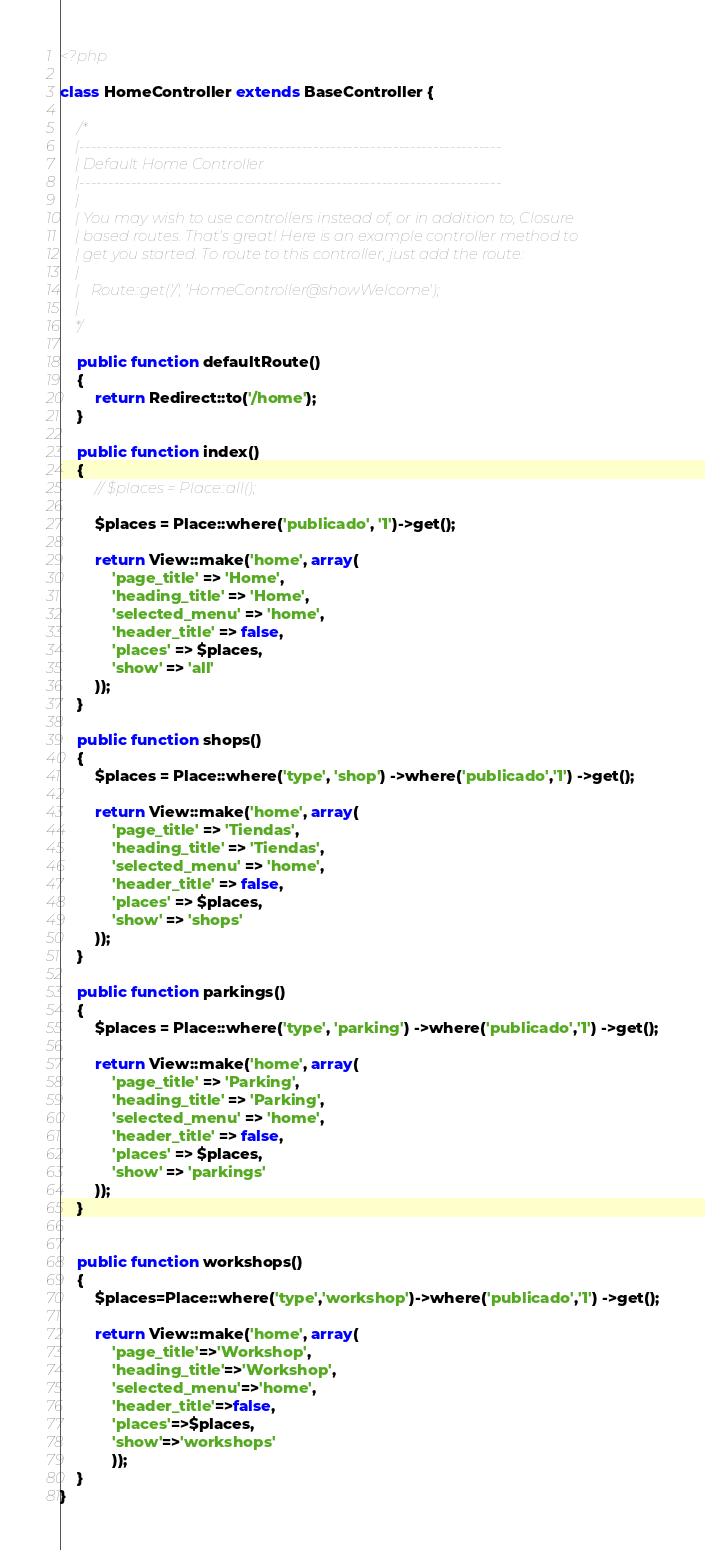<code> <loc_0><loc_0><loc_500><loc_500><_PHP_><?php

class HomeController extends BaseController {

	/*
	|--------------------------------------------------------------------------
	| Default Home Controller
	|--------------------------------------------------------------------------
	|
	| You may wish to use controllers instead of, or in addition to, Closure
	| based routes. That's great! Here is an example controller method to
	| get you started. To route to this controller, just add the route:
	|
	|	Route::get('/', 'HomeController@showWelcome');
	|
	*/

    public function defaultRoute()
    {
        return Redirect::to('/home');
    }

	public function index()
	{
        // $places = Place::all();

        $places = Place::where('publicado', '1')->get();

		return View::make('home', array(
            'page_title' => 'Home',
            'heading_title' => 'Home',
            'selected_menu' => 'home',
            'header_title' => false,
            'places' => $places,
            'show' => 'all'
        ));
	}

    public function shops()
    {
        $places = Place::where('type', 'shop') ->where('publicado','1') ->get();

        return View::make('home', array(
            'page_title' => 'Tiendas',
            'heading_title' => 'Tiendas',
            'selected_menu' => 'home',
            'header_title' => false,
            'places' => $places,
            'show' => 'shops'
        ));
    }

    public function parkings()
    {
        $places = Place::where('type', 'parking') ->where('publicado','1') ->get();

        return View::make('home', array(
            'page_title' => 'Parking',
            'heading_title' => 'Parking',
            'selected_menu' => 'home',
            'header_title' => false,
            'places' => $places,
            'show' => 'parkings'
        ));
    }


    public function workshops()
    {
        $places=Place::where('type','workshop')->where('publicado','1') ->get();

        return View::make('home', array(
            'page_title'=>'Workshop',
            'heading_title'=>'Workshop',
            'selected_menu'=>'home',
            'header_title'=>false,
            'places'=>$places,
            'show'=>'workshops'
            ));
    }
}
</code> 